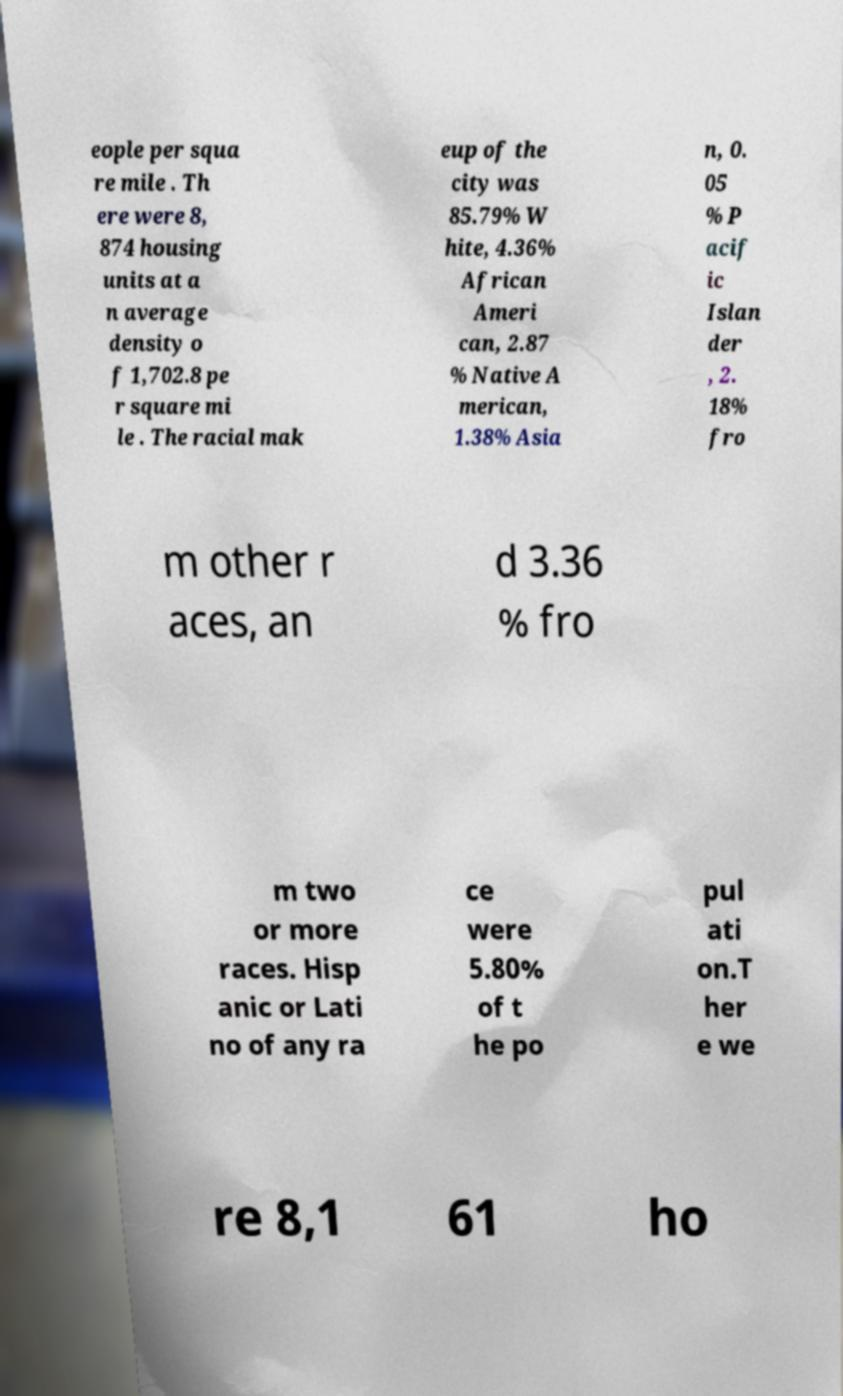Can you read and provide the text displayed in the image?This photo seems to have some interesting text. Can you extract and type it out for me? eople per squa re mile . Th ere were 8, 874 housing units at a n average density o f 1,702.8 pe r square mi le . The racial mak eup of the city was 85.79% W hite, 4.36% African Ameri can, 2.87 % Native A merican, 1.38% Asia n, 0. 05 % P acif ic Islan der , 2. 18% fro m other r aces, an d 3.36 % fro m two or more races. Hisp anic or Lati no of any ra ce were 5.80% of t he po pul ati on.T her e we re 8,1 61 ho 